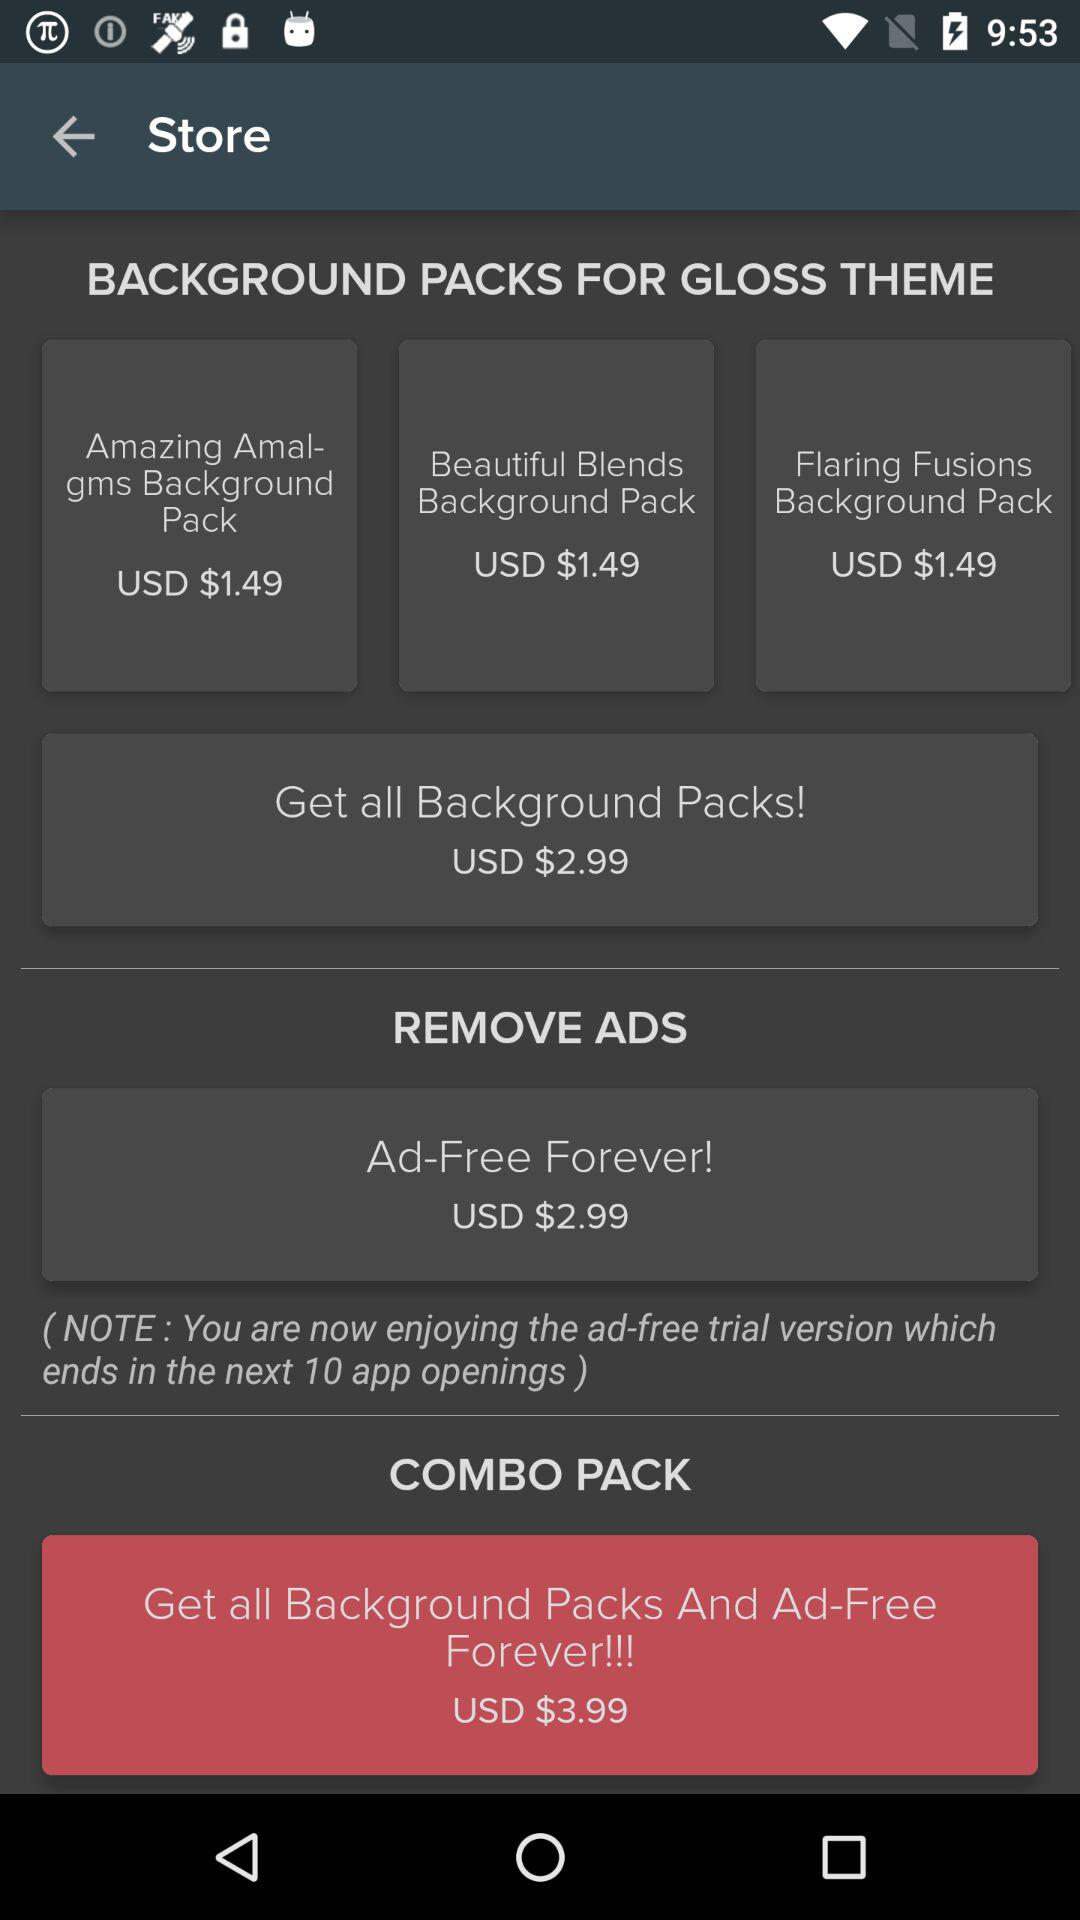How much is the price of the "Flaring Fusions Background Pack"? The price of the "Flaring Fusions Background Pack" is USD $1.49. 